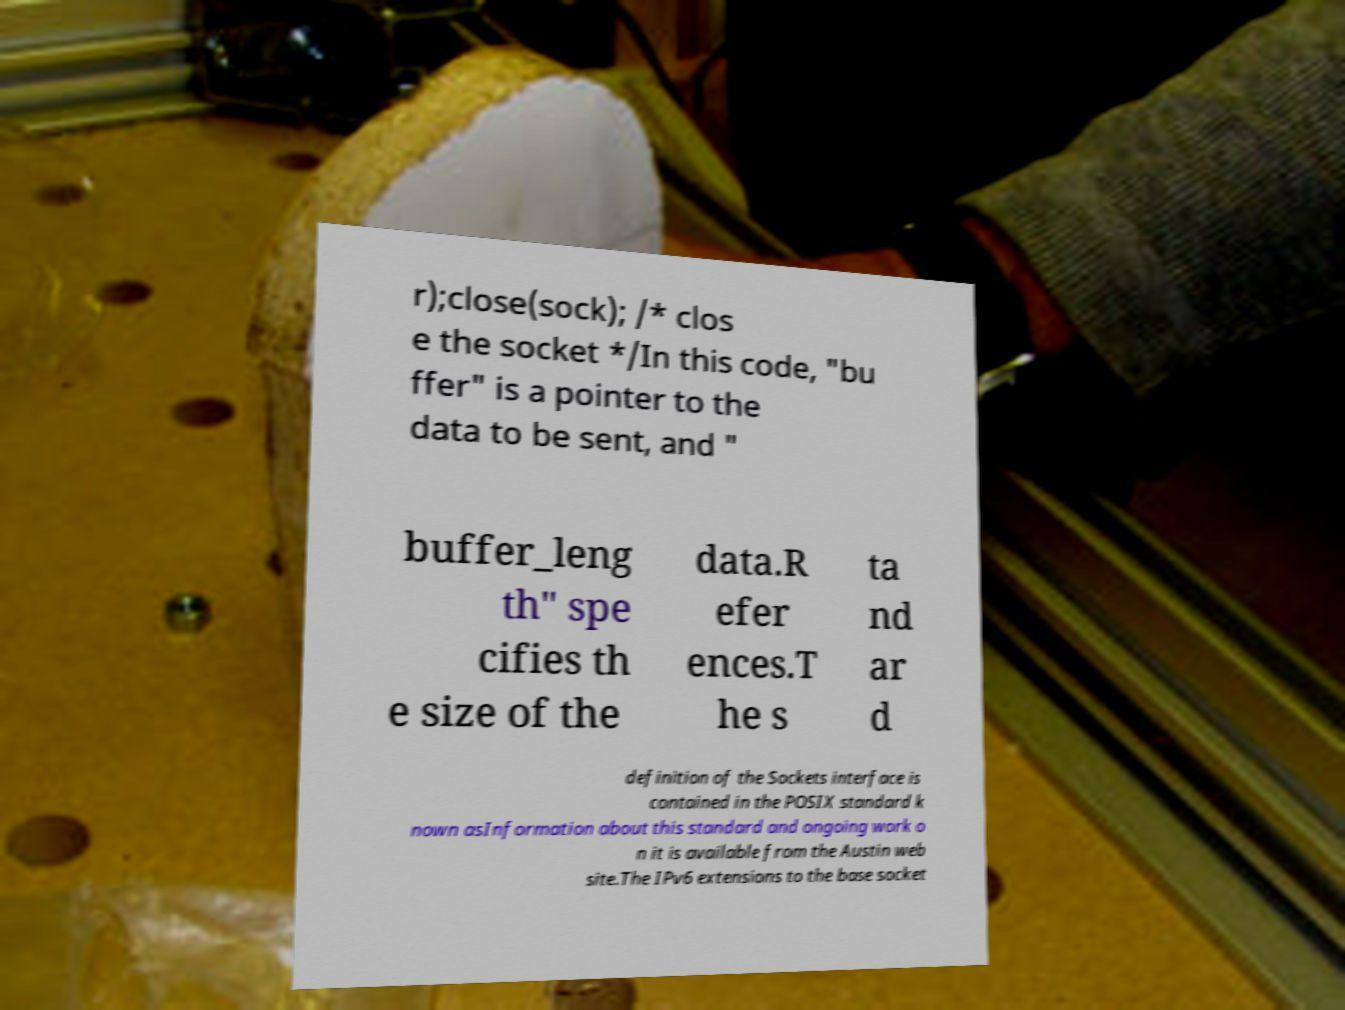Please identify and transcribe the text found in this image. r);close(sock); /* clos e the socket */In this code, "bu ffer" is a pointer to the data to be sent, and " buffer_leng th" spe cifies th e size of the data.R efer ences.T he s ta nd ar d definition of the Sockets interface is contained in the POSIX standard k nown asInformation about this standard and ongoing work o n it is available from the Austin web site.The IPv6 extensions to the base socket 